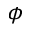Convert formula to latex. <formula><loc_0><loc_0><loc_500><loc_500>\phi</formula> 